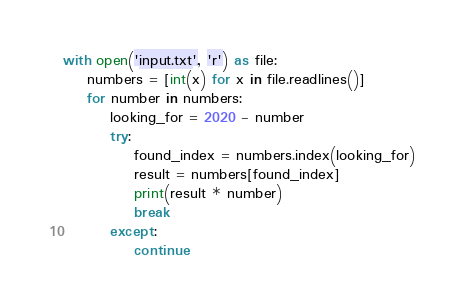Convert code to text. <code><loc_0><loc_0><loc_500><loc_500><_Python_>with open('input.txt', 'r') as file:
    numbers = [int(x) for x in file.readlines()]
    for number in numbers:
        looking_for = 2020 - number
        try:
            found_index = numbers.index(looking_for)
            result = numbers[found_index]
            print(result * number)
            break
        except:
            continue
</code> 